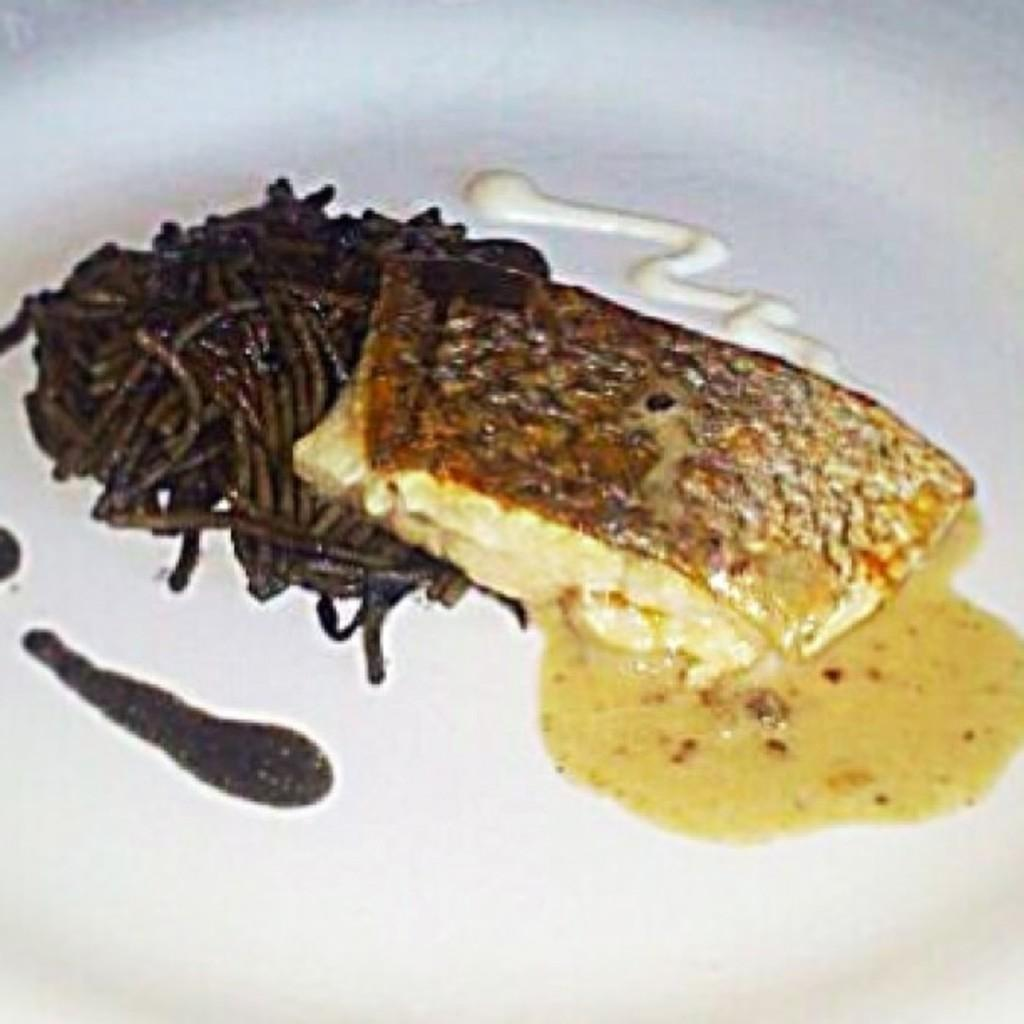What is on the plate in the image? There is food on the plate in the image. Reasoning: Let's think step by step by step in order to produce the conversation. We start by identifying the main subject in the image, which is the plate with food. Then, we formulate a question that focuses on the contents of the plate, ensuring that the language is simple and clear. Absurd Question/Answer: How many toes can be seen on the plate in the image? There are no toes present on the plate in the image. Is there a shelf visible in the image? There is no shelf present in the image. How many legs can be seen on the plate in the image? Plates do not have legs; they are flat objects used for holding food. 